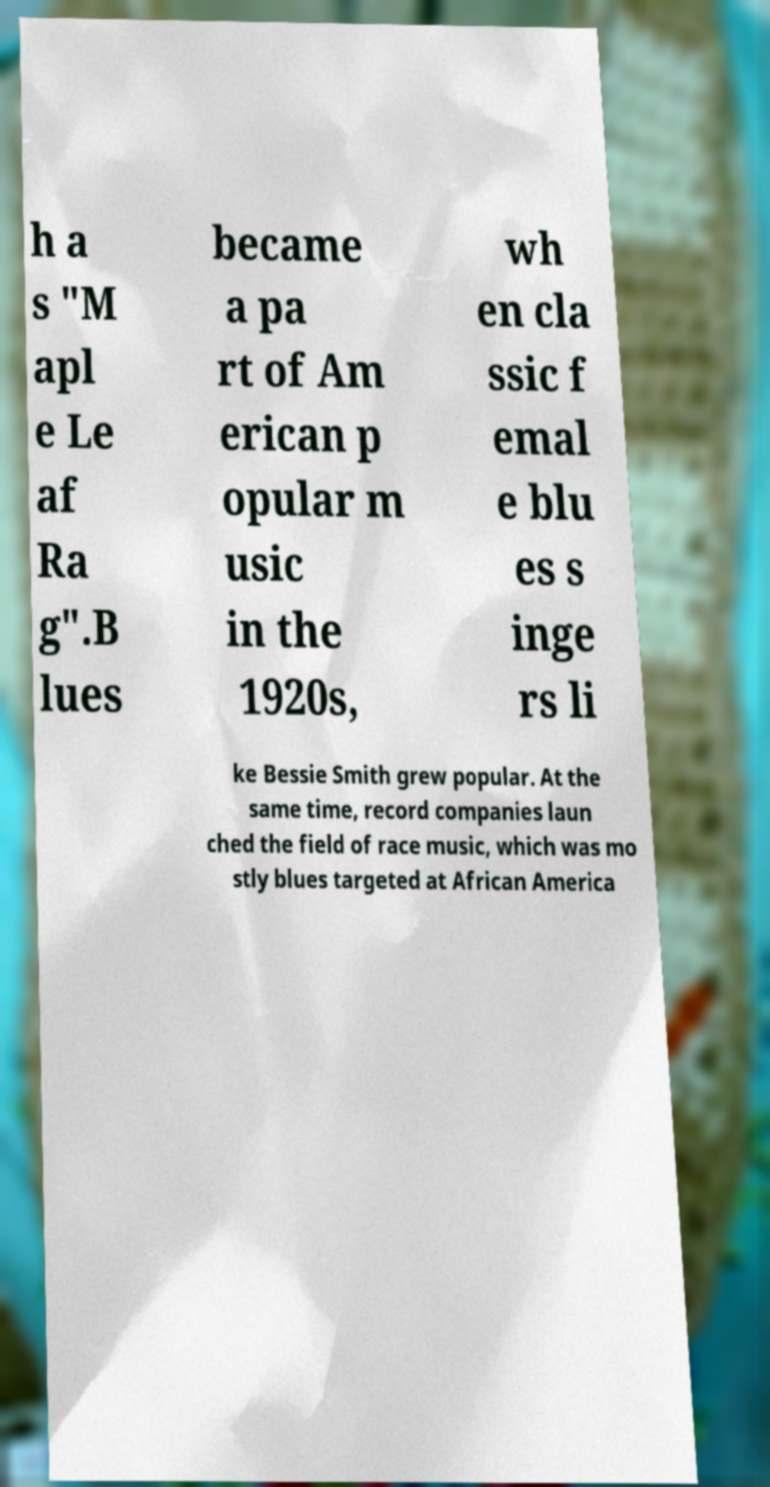Could you extract and type out the text from this image? h a s "M apl e Le af Ra g".B lues became a pa rt of Am erican p opular m usic in the 1920s, wh en cla ssic f emal e blu es s inge rs li ke Bessie Smith grew popular. At the same time, record companies laun ched the field of race music, which was mo stly blues targeted at African America 